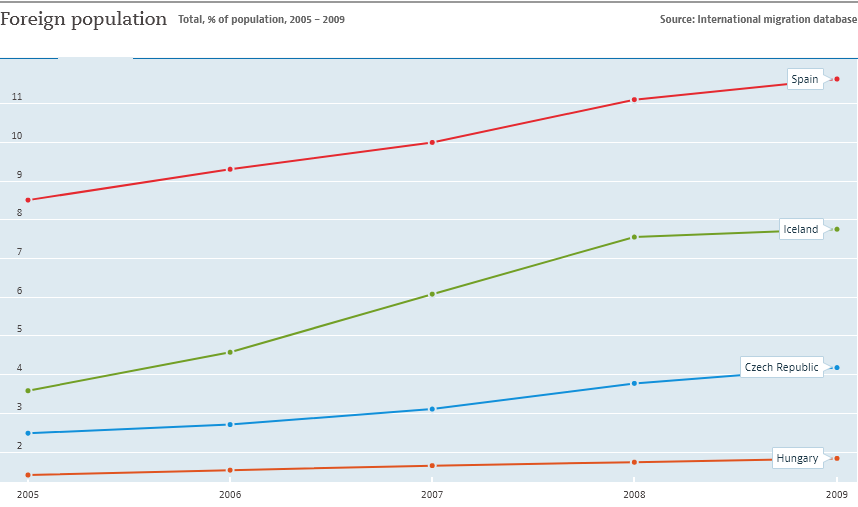Indicate a few pertinent items in this graphic. In 2009, Spain had the highest value among all countries. The green line indicates Iceland. 